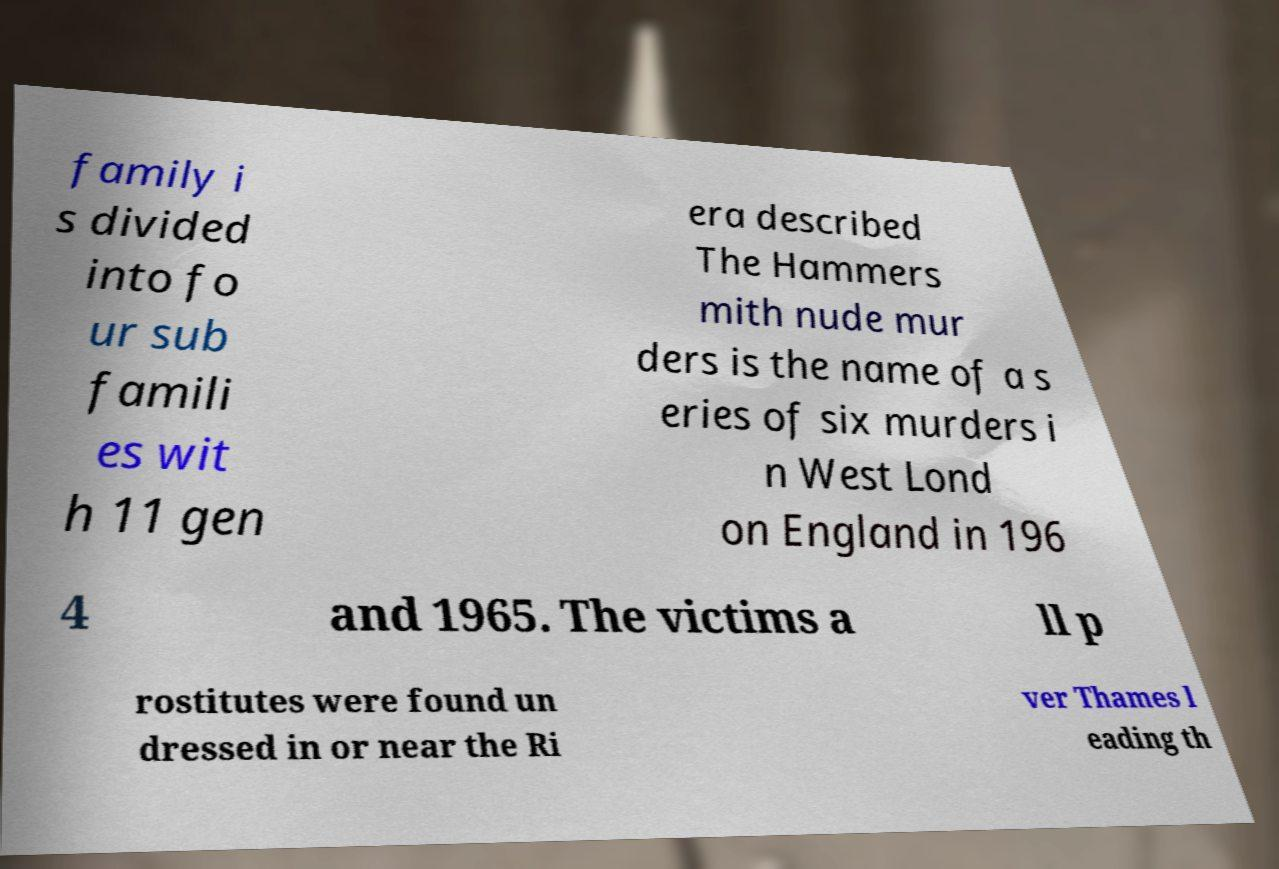Could you extract and type out the text from this image? family i s divided into fo ur sub famili es wit h 11 gen era described The Hammers mith nude mur ders is the name of a s eries of six murders i n West Lond on England in 196 4 and 1965. The victims a ll p rostitutes were found un dressed in or near the Ri ver Thames l eading th 